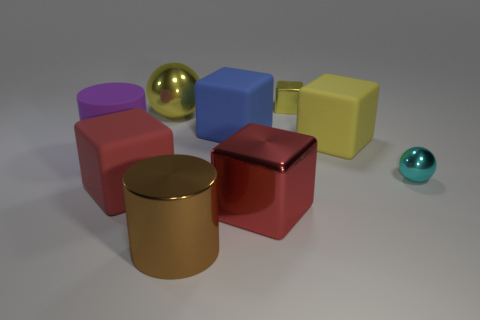What materials seem to be represented by the objects in the image? The image seems to represent objects made from different materials such as polished metal, rubber, and plastic, creating a visually interesting assortment of textures and finishes. 